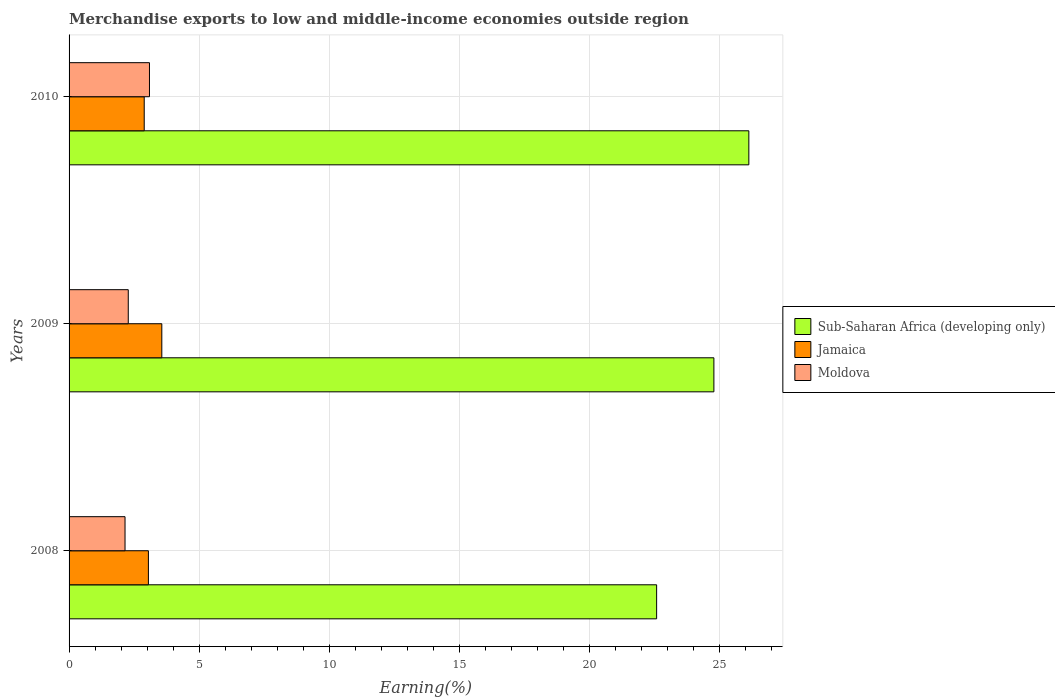Are the number of bars on each tick of the Y-axis equal?
Provide a succinct answer. Yes. What is the label of the 1st group of bars from the top?
Provide a short and direct response. 2010. What is the percentage of amount earned from merchandise exports in Jamaica in 2009?
Provide a short and direct response. 3.56. Across all years, what is the maximum percentage of amount earned from merchandise exports in Sub-Saharan Africa (developing only)?
Make the answer very short. 26.12. Across all years, what is the minimum percentage of amount earned from merchandise exports in Jamaica?
Keep it short and to the point. 2.89. What is the total percentage of amount earned from merchandise exports in Jamaica in the graph?
Your response must be concise. 9.5. What is the difference between the percentage of amount earned from merchandise exports in Sub-Saharan Africa (developing only) in 2009 and that in 2010?
Offer a very short reply. -1.34. What is the difference between the percentage of amount earned from merchandise exports in Sub-Saharan Africa (developing only) in 2010 and the percentage of amount earned from merchandise exports in Moldova in 2008?
Offer a terse response. 23.97. What is the average percentage of amount earned from merchandise exports in Sub-Saharan Africa (developing only) per year?
Make the answer very short. 24.49. In the year 2010, what is the difference between the percentage of amount earned from merchandise exports in Jamaica and percentage of amount earned from merchandise exports in Sub-Saharan Africa (developing only)?
Make the answer very short. -23.23. In how many years, is the percentage of amount earned from merchandise exports in Jamaica greater than 23 %?
Your response must be concise. 0. What is the ratio of the percentage of amount earned from merchandise exports in Sub-Saharan Africa (developing only) in 2008 to that in 2009?
Provide a succinct answer. 0.91. What is the difference between the highest and the second highest percentage of amount earned from merchandise exports in Sub-Saharan Africa (developing only)?
Give a very brief answer. 1.34. What is the difference between the highest and the lowest percentage of amount earned from merchandise exports in Moldova?
Provide a short and direct response. 0.94. In how many years, is the percentage of amount earned from merchandise exports in Jamaica greater than the average percentage of amount earned from merchandise exports in Jamaica taken over all years?
Make the answer very short. 1. What does the 2nd bar from the top in 2008 represents?
Your answer should be compact. Jamaica. What does the 2nd bar from the bottom in 2010 represents?
Offer a very short reply. Jamaica. Are all the bars in the graph horizontal?
Offer a very short reply. Yes. Does the graph contain grids?
Make the answer very short. Yes. Where does the legend appear in the graph?
Your response must be concise. Center right. What is the title of the graph?
Offer a very short reply. Merchandise exports to low and middle-income economies outside region. What is the label or title of the X-axis?
Ensure brevity in your answer.  Earning(%). What is the label or title of the Y-axis?
Ensure brevity in your answer.  Years. What is the Earning(%) of Sub-Saharan Africa (developing only) in 2008?
Keep it short and to the point. 22.58. What is the Earning(%) of Jamaica in 2008?
Your response must be concise. 3.05. What is the Earning(%) in Moldova in 2008?
Offer a terse response. 2.15. What is the Earning(%) of Sub-Saharan Africa (developing only) in 2009?
Keep it short and to the point. 24.78. What is the Earning(%) of Jamaica in 2009?
Provide a short and direct response. 3.56. What is the Earning(%) in Moldova in 2009?
Your answer should be compact. 2.27. What is the Earning(%) of Sub-Saharan Africa (developing only) in 2010?
Provide a short and direct response. 26.12. What is the Earning(%) of Jamaica in 2010?
Provide a short and direct response. 2.89. What is the Earning(%) in Moldova in 2010?
Ensure brevity in your answer.  3.09. Across all years, what is the maximum Earning(%) in Sub-Saharan Africa (developing only)?
Make the answer very short. 26.12. Across all years, what is the maximum Earning(%) in Jamaica?
Ensure brevity in your answer.  3.56. Across all years, what is the maximum Earning(%) in Moldova?
Make the answer very short. 3.09. Across all years, what is the minimum Earning(%) of Sub-Saharan Africa (developing only)?
Keep it short and to the point. 22.58. Across all years, what is the minimum Earning(%) in Jamaica?
Your answer should be very brief. 2.89. Across all years, what is the minimum Earning(%) in Moldova?
Your response must be concise. 2.15. What is the total Earning(%) of Sub-Saharan Africa (developing only) in the graph?
Give a very brief answer. 73.47. What is the total Earning(%) in Jamaica in the graph?
Keep it short and to the point. 9.5. What is the total Earning(%) of Moldova in the graph?
Your response must be concise. 7.51. What is the difference between the Earning(%) in Sub-Saharan Africa (developing only) in 2008 and that in 2009?
Your answer should be very brief. -2.2. What is the difference between the Earning(%) of Jamaica in 2008 and that in 2009?
Make the answer very short. -0.52. What is the difference between the Earning(%) of Moldova in 2008 and that in 2009?
Keep it short and to the point. -0.12. What is the difference between the Earning(%) in Sub-Saharan Africa (developing only) in 2008 and that in 2010?
Offer a very short reply. -3.54. What is the difference between the Earning(%) of Jamaica in 2008 and that in 2010?
Your response must be concise. 0.16. What is the difference between the Earning(%) of Moldova in 2008 and that in 2010?
Your answer should be very brief. -0.94. What is the difference between the Earning(%) in Sub-Saharan Africa (developing only) in 2009 and that in 2010?
Provide a succinct answer. -1.34. What is the difference between the Earning(%) of Jamaica in 2009 and that in 2010?
Offer a very short reply. 0.68. What is the difference between the Earning(%) of Moldova in 2009 and that in 2010?
Provide a short and direct response. -0.81. What is the difference between the Earning(%) in Sub-Saharan Africa (developing only) in 2008 and the Earning(%) in Jamaica in 2009?
Your answer should be compact. 19.01. What is the difference between the Earning(%) of Sub-Saharan Africa (developing only) in 2008 and the Earning(%) of Moldova in 2009?
Ensure brevity in your answer.  20.3. What is the difference between the Earning(%) in Jamaica in 2008 and the Earning(%) in Moldova in 2009?
Offer a very short reply. 0.77. What is the difference between the Earning(%) in Sub-Saharan Africa (developing only) in 2008 and the Earning(%) in Jamaica in 2010?
Your answer should be compact. 19.69. What is the difference between the Earning(%) of Sub-Saharan Africa (developing only) in 2008 and the Earning(%) of Moldova in 2010?
Your answer should be compact. 19.49. What is the difference between the Earning(%) in Jamaica in 2008 and the Earning(%) in Moldova in 2010?
Keep it short and to the point. -0.04. What is the difference between the Earning(%) in Sub-Saharan Africa (developing only) in 2009 and the Earning(%) in Jamaica in 2010?
Provide a succinct answer. 21.89. What is the difference between the Earning(%) of Sub-Saharan Africa (developing only) in 2009 and the Earning(%) of Moldova in 2010?
Your answer should be compact. 21.69. What is the difference between the Earning(%) of Jamaica in 2009 and the Earning(%) of Moldova in 2010?
Offer a very short reply. 0.47. What is the average Earning(%) of Sub-Saharan Africa (developing only) per year?
Make the answer very short. 24.49. What is the average Earning(%) of Jamaica per year?
Keep it short and to the point. 3.17. What is the average Earning(%) in Moldova per year?
Your answer should be compact. 2.5. In the year 2008, what is the difference between the Earning(%) of Sub-Saharan Africa (developing only) and Earning(%) of Jamaica?
Give a very brief answer. 19.53. In the year 2008, what is the difference between the Earning(%) of Sub-Saharan Africa (developing only) and Earning(%) of Moldova?
Ensure brevity in your answer.  20.43. In the year 2008, what is the difference between the Earning(%) in Jamaica and Earning(%) in Moldova?
Provide a short and direct response. 0.9. In the year 2009, what is the difference between the Earning(%) in Sub-Saharan Africa (developing only) and Earning(%) in Jamaica?
Keep it short and to the point. 21.21. In the year 2009, what is the difference between the Earning(%) of Sub-Saharan Africa (developing only) and Earning(%) of Moldova?
Your answer should be very brief. 22.5. In the year 2009, what is the difference between the Earning(%) of Jamaica and Earning(%) of Moldova?
Offer a terse response. 1.29. In the year 2010, what is the difference between the Earning(%) in Sub-Saharan Africa (developing only) and Earning(%) in Jamaica?
Keep it short and to the point. 23.23. In the year 2010, what is the difference between the Earning(%) of Sub-Saharan Africa (developing only) and Earning(%) of Moldova?
Make the answer very short. 23.03. In the year 2010, what is the difference between the Earning(%) of Jamaica and Earning(%) of Moldova?
Give a very brief answer. -0.2. What is the ratio of the Earning(%) of Sub-Saharan Africa (developing only) in 2008 to that in 2009?
Offer a terse response. 0.91. What is the ratio of the Earning(%) in Jamaica in 2008 to that in 2009?
Your answer should be compact. 0.86. What is the ratio of the Earning(%) in Moldova in 2008 to that in 2009?
Offer a terse response. 0.95. What is the ratio of the Earning(%) of Sub-Saharan Africa (developing only) in 2008 to that in 2010?
Ensure brevity in your answer.  0.86. What is the ratio of the Earning(%) in Jamaica in 2008 to that in 2010?
Your response must be concise. 1.06. What is the ratio of the Earning(%) of Moldova in 2008 to that in 2010?
Your response must be concise. 0.7. What is the ratio of the Earning(%) in Sub-Saharan Africa (developing only) in 2009 to that in 2010?
Your answer should be compact. 0.95. What is the ratio of the Earning(%) in Jamaica in 2009 to that in 2010?
Ensure brevity in your answer.  1.23. What is the ratio of the Earning(%) of Moldova in 2009 to that in 2010?
Give a very brief answer. 0.74. What is the difference between the highest and the second highest Earning(%) of Sub-Saharan Africa (developing only)?
Make the answer very short. 1.34. What is the difference between the highest and the second highest Earning(%) of Jamaica?
Your response must be concise. 0.52. What is the difference between the highest and the second highest Earning(%) in Moldova?
Your answer should be compact. 0.81. What is the difference between the highest and the lowest Earning(%) of Sub-Saharan Africa (developing only)?
Provide a succinct answer. 3.54. What is the difference between the highest and the lowest Earning(%) of Jamaica?
Offer a terse response. 0.68. What is the difference between the highest and the lowest Earning(%) of Moldova?
Your answer should be compact. 0.94. 